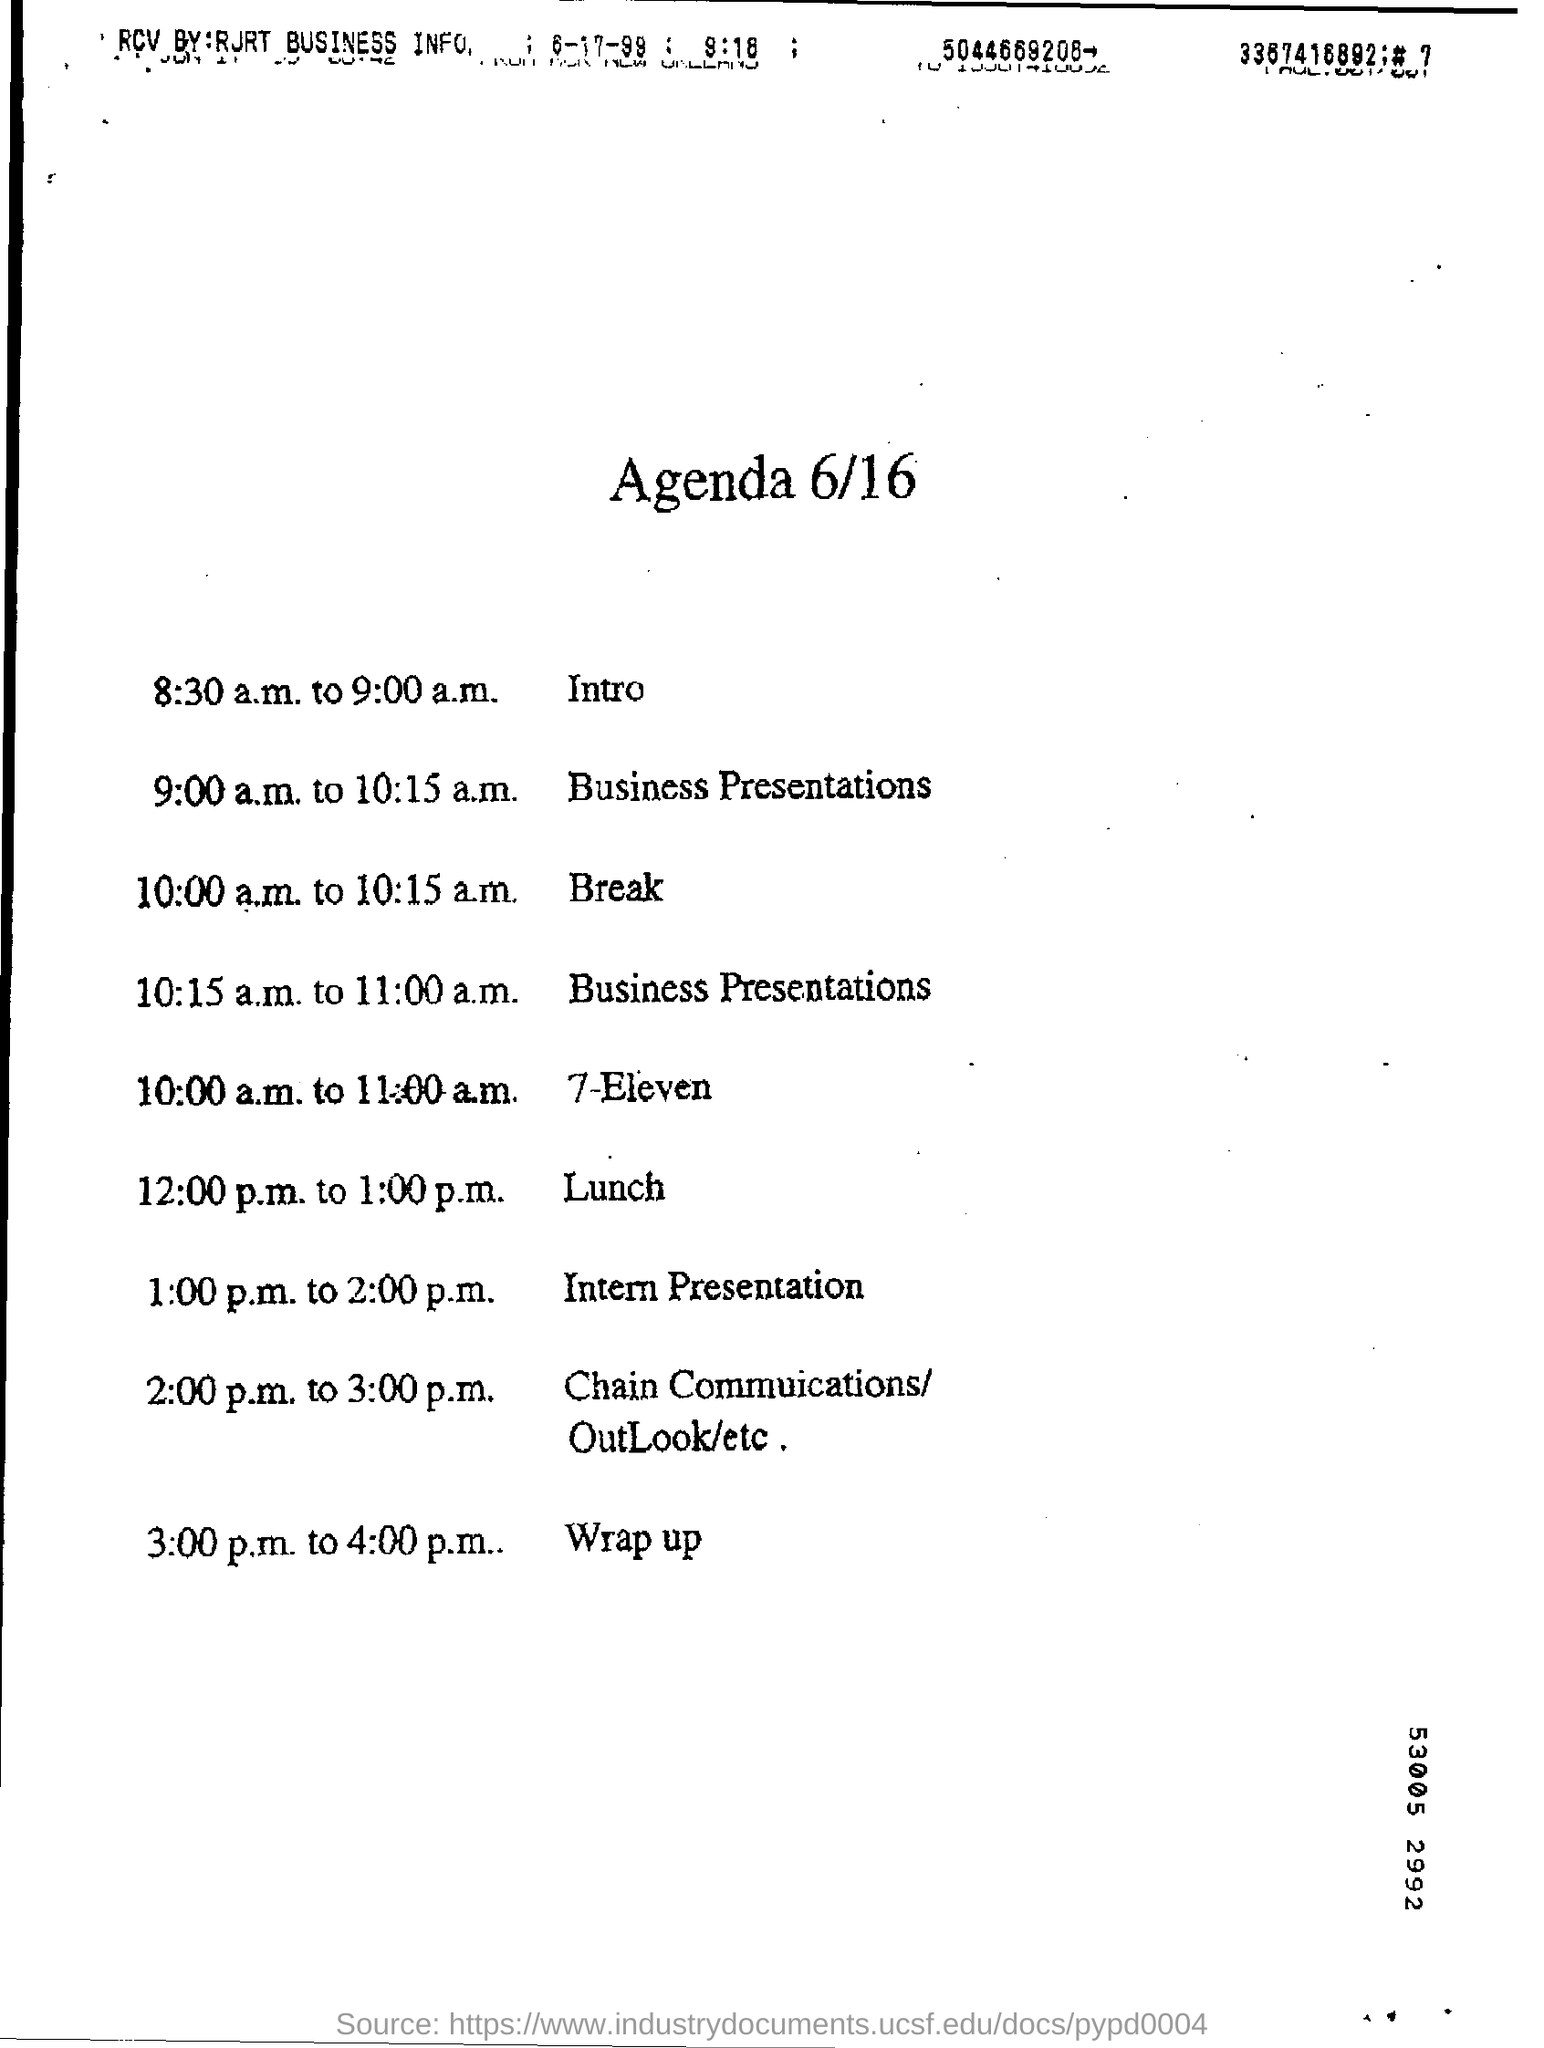What is the time of intro?
Ensure brevity in your answer.  8:30 a.m. to 9:00 a.m. What was the break time?
Keep it short and to the point. 10:00 a.m. to 10:15 a.m. 